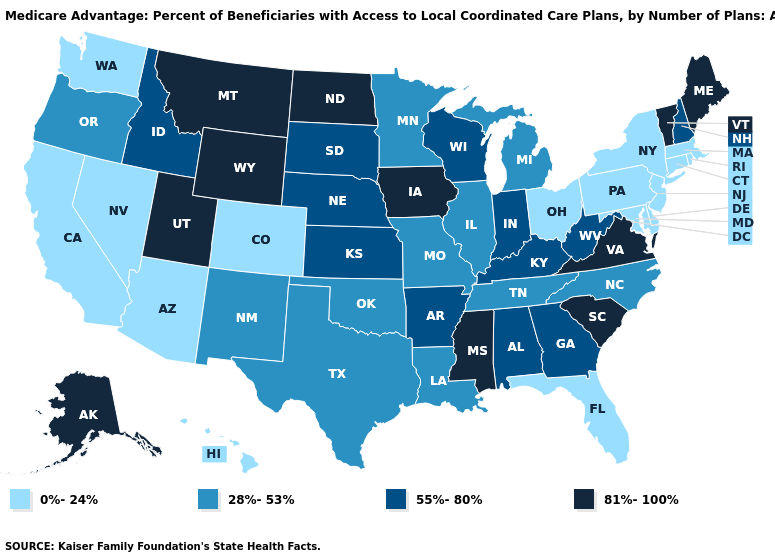Among the states that border Kansas , does Colorado have the highest value?
Be succinct. No. What is the highest value in the USA?
Concise answer only. 81%-100%. How many symbols are there in the legend?
Keep it brief. 4. What is the value of Wyoming?
Quick response, please. 81%-100%. Name the states that have a value in the range 28%-53%?
Give a very brief answer. Illinois, Louisiana, Michigan, Minnesota, Missouri, North Carolina, New Mexico, Oklahoma, Oregon, Tennessee, Texas. Among the states that border Maine , which have the lowest value?
Short answer required. New Hampshire. Name the states that have a value in the range 81%-100%?
Concise answer only. Alaska, Iowa, Maine, Mississippi, Montana, North Dakota, South Carolina, Utah, Virginia, Vermont, Wyoming. Is the legend a continuous bar?
Short answer required. No. What is the value of Hawaii?
Give a very brief answer. 0%-24%. Which states have the lowest value in the USA?
Be succinct. Arizona, California, Colorado, Connecticut, Delaware, Florida, Hawaii, Massachusetts, Maryland, New Jersey, Nevada, New York, Ohio, Pennsylvania, Rhode Island, Washington. What is the lowest value in the South?
Give a very brief answer. 0%-24%. What is the value of Virginia?
Write a very short answer. 81%-100%. What is the highest value in the USA?
Concise answer only. 81%-100%. Among the states that border Rhode Island , which have the highest value?
Answer briefly. Connecticut, Massachusetts. Which states have the lowest value in the Northeast?
Concise answer only. Connecticut, Massachusetts, New Jersey, New York, Pennsylvania, Rhode Island. 